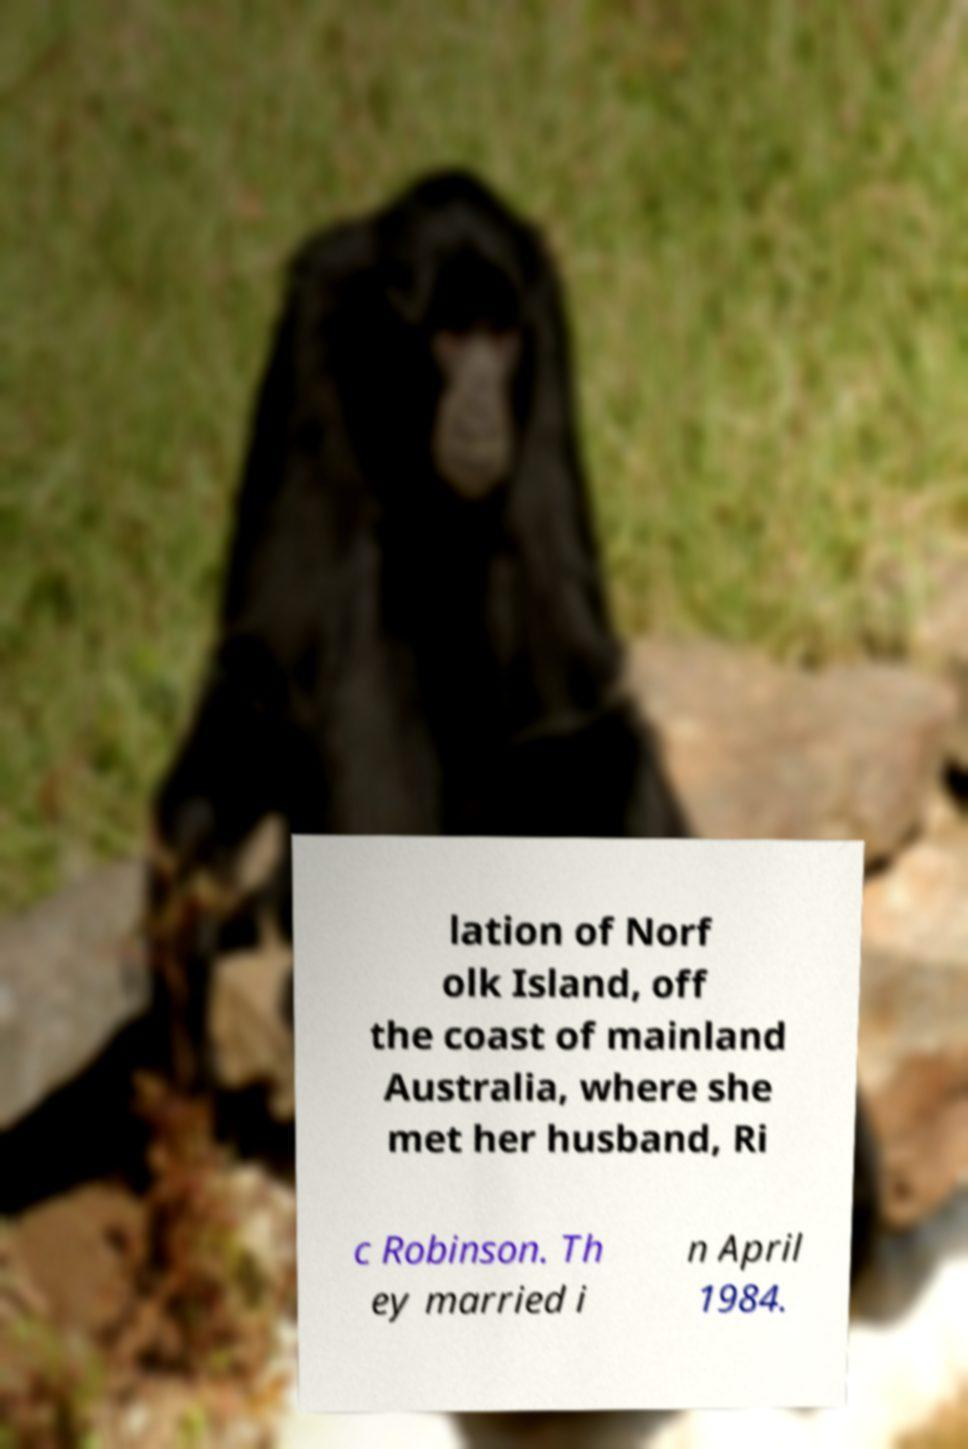Could you assist in decoding the text presented in this image and type it out clearly? lation of Norf olk Island, off the coast of mainland Australia, where she met her husband, Ri c Robinson. Th ey married i n April 1984. 